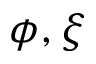Convert formula to latex. <formula><loc_0><loc_0><loc_500><loc_500>\phi , \xi</formula> 